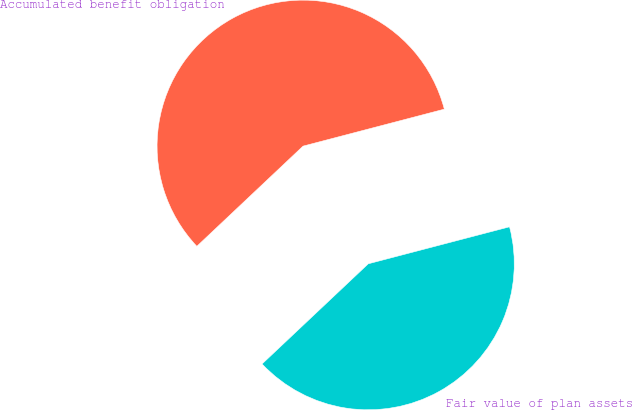<chart> <loc_0><loc_0><loc_500><loc_500><pie_chart><fcel>Accumulated benefit obligation<fcel>Fair value of plan assets<nl><fcel>57.96%<fcel>42.04%<nl></chart> 